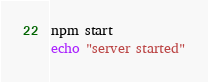Convert code to text. <code><loc_0><loc_0><loc_500><loc_500><_Bash_>npm start
echo "server started"
</code> 